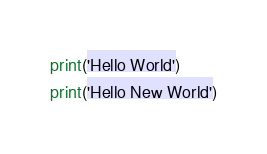Convert code to text. <code><loc_0><loc_0><loc_500><loc_500><_Python_>print('Hello World')
print('Hello New World')
</code> 